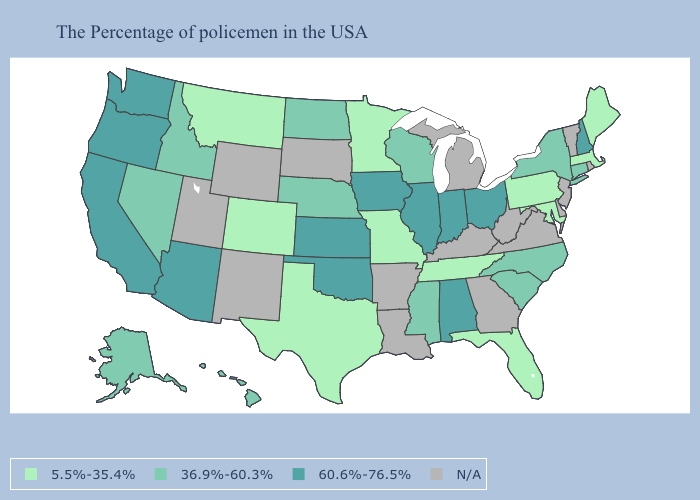Which states have the highest value in the USA?
Answer briefly. New Hampshire, Ohio, Indiana, Alabama, Illinois, Iowa, Kansas, Oklahoma, Arizona, California, Washington, Oregon. What is the highest value in the Northeast ?
Keep it brief. 60.6%-76.5%. Which states hav the highest value in the South?
Write a very short answer. Alabama, Oklahoma. What is the value of Colorado?
Answer briefly. 5.5%-35.4%. Is the legend a continuous bar?
Be succinct. No. Name the states that have a value in the range 36.9%-60.3%?
Short answer required. Connecticut, New York, North Carolina, South Carolina, Wisconsin, Mississippi, Nebraska, North Dakota, Idaho, Nevada, Alaska, Hawaii. Among the states that border Massachusetts , which have the highest value?
Answer briefly. New Hampshire. Name the states that have a value in the range 36.9%-60.3%?
Answer briefly. Connecticut, New York, North Carolina, South Carolina, Wisconsin, Mississippi, Nebraska, North Dakota, Idaho, Nevada, Alaska, Hawaii. Which states have the lowest value in the South?
Concise answer only. Maryland, Florida, Tennessee, Texas. Name the states that have a value in the range 5.5%-35.4%?
Concise answer only. Maine, Massachusetts, Maryland, Pennsylvania, Florida, Tennessee, Missouri, Minnesota, Texas, Colorado, Montana. What is the value of Rhode Island?
Keep it brief. N/A. Which states have the lowest value in the USA?
Short answer required. Maine, Massachusetts, Maryland, Pennsylvania, Florida, Tennessee, Missouri, Minnesota, Texas, Colorado, Montana. Name the states that have a value in the range 5.5%-35.4%?
Concise answer only. Maine, Massachusetts, Maryland, Pennsylvania, Florida, Tennessee, Missouri, Minnesota, Texas, Colorado, Montana. Does South Carolina have the lowest value in the USA?
Keep it brief. No. Among the states that border Florida , which have the highest value?
Quick response, please. Alabama. 